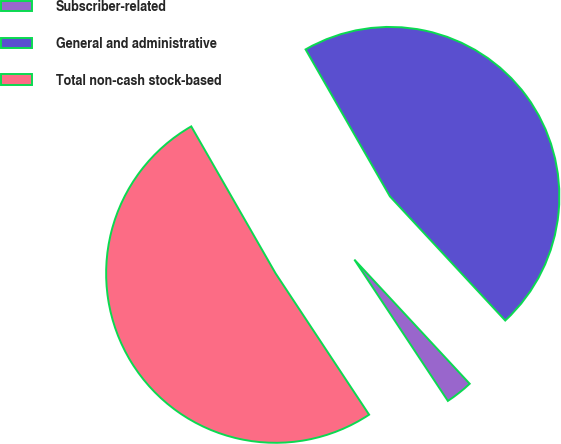Convert chart. <chart><loc_0><loc_0><loc_500><loc_500><pie_chart><fcel>Subscriber-related<fcel>General and administrative<fcel>Total non-cash stock-based<nl><fcel>2.61%<fcel>46.38%<fcel>51.02%<nl></chart> 